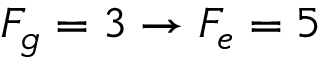Convert formula to latex. <formula><loc_0><loc_0><loc_500><loc_500>F _ { g } = 3 \rightarrow F _ { e } = 5</formula> 